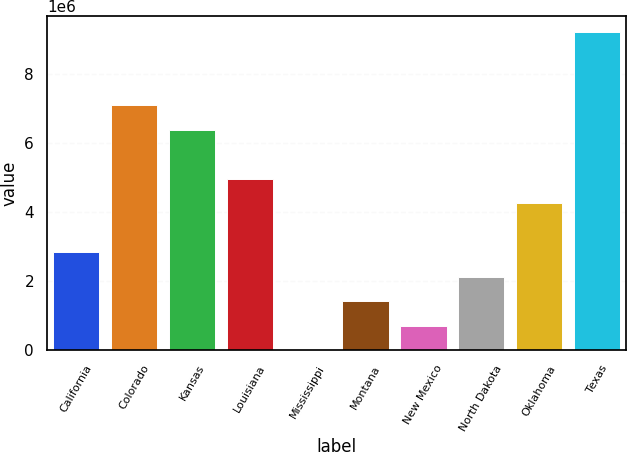Convert chart. <chart><loc_0><loc_0><loc_500><loc_500><bar_chart><fcel>California<fcel>Colorado<fcel>Kansas<fcel>Louisiana<fcel>Mississippi<fcel>Montana<fcel>New Mexico<fcel>North Dakota<fcel>Oklahoma<fcel>Texas<nl><fcel>2.83474e+06<fcel>7.08676e+06<fcel>6.37809e+06<fcel>4.96075e+06<fcel>51<fcel>1.41739e+06<fcel>708722<fcel>2.12606e+06<fcel>4.25208e+06<fcel>9.21277e+06<nl></chart> 